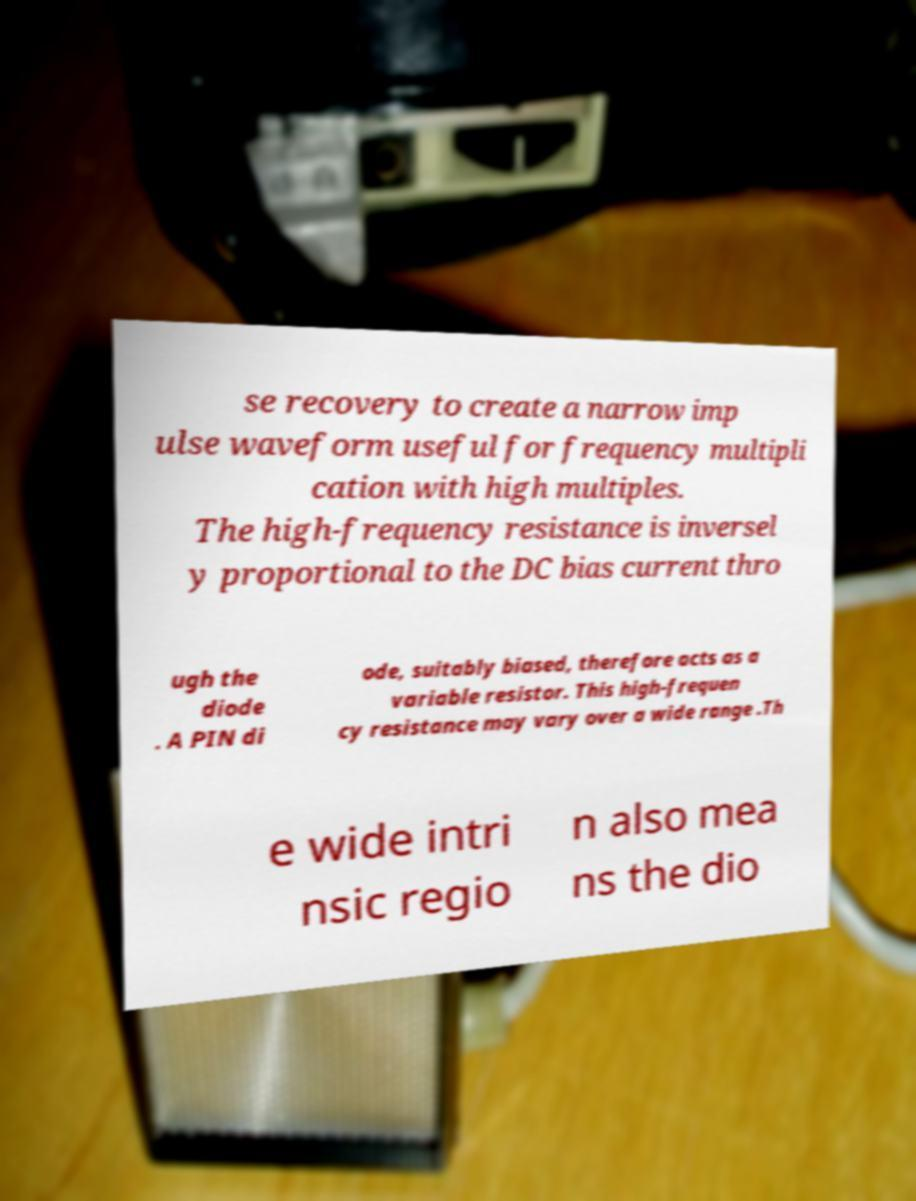Please read and relay the text visible in this image. What does it say? se recovery to create a narrow imp ulse waveform useful for frequency multipli cation with high multiples. The high-frequency resistance is inversel y proportional to the DC bias current thro ugh the diode . A PIN di ode, suitably biased, therefore acts as a variable resistor. This high-frequen cy resistance may vary over a wide range .Th e wide intri nsic regio n also mea ns the dio 